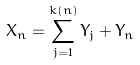Convert formula to latex. <formula><loc_0><loc_0><loc_500><loc_500>X _ { n } = \sum _ { j = 1 } ^ { k ( n ) } Y _ { j } + \bar { Y } _ { n }</formula> 